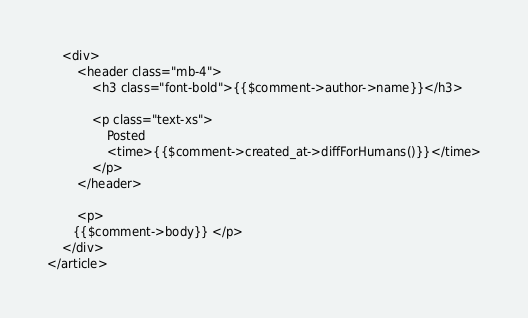<code> <loc_0><loc_0><loc_500><loc_500><_PHP_>    <div>
        <header class="mb-4">
            <h3 class="font-bold">{{$comment->author->name}}</h3>

            <p class="text-xs">
                Posted
                <time>{{$comment->created_at->diffForHumans()}}</time>
            </p>
        </header>

        <p>
       {{$comment->body}} </p>
    </div>
</article>
</code> 